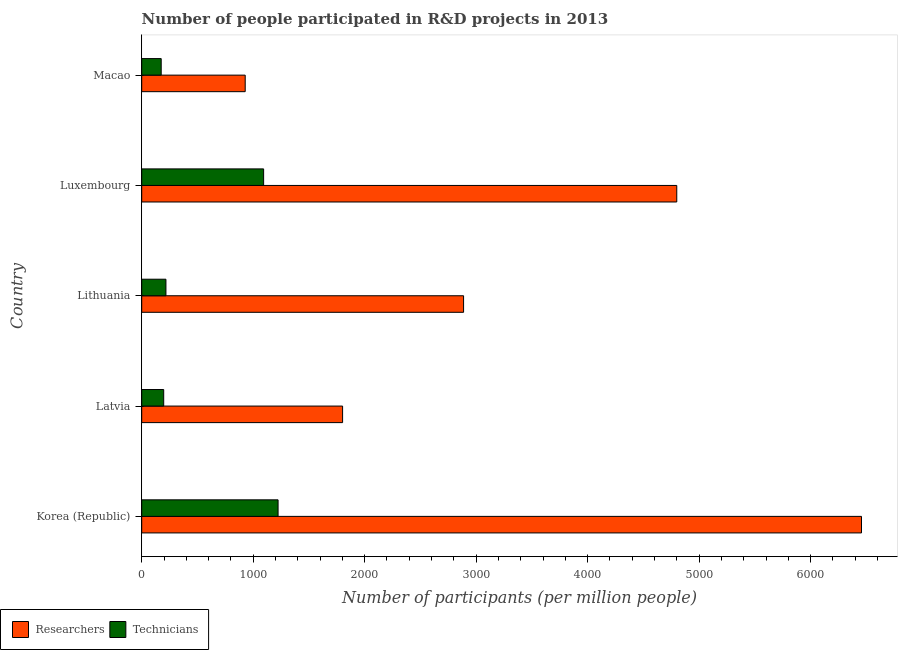How many groups of bars are there?
Your answer should be compact. 5. Are the number of bars on each tick of the Y-axis equal?
Your answer should be very brief. Yes. How many bars are there on the 3rd tick from the top?
Ensure brevity in your answer.  2. What is the label of the 4th group of bars from the top?
Offer a terse response. Latvia. In how many cases, is the number of bars for a given country not equal to the number of legend labels?
Give a very brief answer. 0. What is the number of researchers in Korea (Republic)?
Give a very brief answer. 6456.63. Across all countries, what is the maximum number of researchers?
Make the answer very short. 6456.63. Across all countries, what is the minimum number of technicians?
Provide a short and direct response. 174.68. In which country was the number of researchers minimum?
Keep it short and to the point. Macao. What is the total number of researchers in the graph?
Provide a short and direct response. 1.69e+04. What is the difference between the number of researchers in Korea (Republic) and that in Macao?
Offer a very short reply. 5528.37. What is the difference between the number of researchers in Luxembourg and the number of technicians in Macao?
Provide a short and direct response. 4624.86. What is the average number of researchers per country?
Give a very brief answer. 3374.68. What is the difference between the number of technicians and number of researchers in Luxembourg?
Your response must be concise. -3706.07. In how many countries, is the number of researchers greater than 800 ?
Provide a succinct answer. 5. What is the ratio of the number of technicians in Lithuania to that in Luxembourg?
Provide a short and direct response. 0.2. Is the difference between the number of researchers in Korea (Republic) and Luxembourg greater than the difference between the number of technicians in Korea (Republic) and Luxembourg?
Ensure brevity in your answer.  Yes. What is the difference between the highest and the second highest number of technicians?
Your response must be concise. 129.68. What is the difference between the highest and the lowest number of technicians?
Provide a short and direct response. 1048.47. In how many countries, is the number of technicians greater than the average number of technicians taken over all countries?
Give a very brief answer. 2. Is the sum of the number of technicians in Korea (Republic) and Luxembourg greater than the maximum number of researchers across all countries?
Provide a short and direct response. No. What does the 2nd bar from the top in Luxembourg represents?
Ensure brevity in your answer.  Researchers. What does the 1st bar from the bottom in Lithuania represents?
Give a very brief answer. Researchers. How many bars are there?
Keep it short and to the point. 10. Does the graph contain any zero values?
Your response must be concise. No. Does the graph contain grids?
Keep it short and to the point. No. Where does the legend appear in the graph?
Your response must be concise. Bottom left. What is the title of the graph?
Offer a terse response. Number of people participated in R&D projects in 2013. What is the label or title of the X-axis?
Offer a very short reply. Number of participants (per million people). What is the label or title of the Y-axis?
Offer a very short reply. Country. What is the Number of participants (per million people) in Researchers in Korea (Republic)?
Offer a terse response. 6456.63. What is the Number of participants (per million people) in Technicians in Korea (Republic)?
Your answer should be compact. 1223.15. What is the Number of participants (per million people) of Researchers in Latvia?
Your answer should be compact. 1801.82. What is the Number of participants (per million people) in Technicians in Latvia?
Give a very brief answer. 197.2. What is the Number of participants (per million people) of Researchers in Lithuania?
Your answer should be compact. 2887.16. What is the Number of participants (per million people) of Technicians in Lithuania?
Provide a succinct answer. 217.23. What is the Number of participants (per million people) of Researchers in Luxembourg?
Your answer should be very brief. 4799.54. What is the Number of participants (per million people) in Technicians in Luxembourg?
Keep it short and to the point. 1093.47. What is the Number of participants (per million people) in Researchers in Macao?
Offer a very short reply. 928.25. What is the Number of participants (per million people) in Technicians in Macao?
Make the answer very short. 174.68. Across all countries, what is the maximum Number of participants (per million people) of Researchers?
Make the answer very short. 6456.63. Across all countries, what is the maximum Number of participants (per million people) in Technicians?
Give a very brief answer. 1223.15. Across all countries, what is the minimum Number of participants (per million people) in Researchers?
Ensure brevity in your answer.  928.25. Across all countries, what is the minimum Number of participants (per million people) in Technicians?
Your answer should be compact. 174.68. What is the total Number of participants (per million people) of Researchers in the graph?
Offer a terse response. 1.69e+04. What is the total Number of participants (per million people) in Technicians in the graph?
Ensure brevity in your answer.  2905.73. What is the difference between the Number of participants (per million people) in Researchers in Korea (Republic) and that in Latvia?
Make the answer very short. 4654.81. What is the difference between the Number of participants (per million people) in Technicians in Korea (Republic) and that in Latvia?
Offer a terse response. 1025.95. What is the difference between the Number of participants (per million people) in Researchers in Korea (Republic) and that in Lithuania?
Your answer should be very brief. 3569.46. What is the difference between the Number of participants (per million people) in Technicians in Korea (Republic) and that in Lithuania?
Your answer should be compact. 1005.92. What is the difference between the Number of participants (per million people) in Researchers in Korea (Republic) and that in Luxembourg?
Make the answer very short. 1657.08. What is the difference between the Number of participants (per million people) of Technicians in Korea (Republic) and that in Luxembourg?
Your answer should be compact. 129.68. What is the difference between the Number of participants (per million people) of Researchers in Korea (Republic) and that in Macao?
Provide a short and direct response. 5528.37. What is the difference between the Number of participants (per million people) of Technicians in Korea (Republic) and that in Macao?
Offer a terse response. 1048.47. What is the difference between the Number of participants (per million people) of Researchers in Latvia and that in Lithuania?
Give a very brief answer. -1085.34. What is the difference between the Number of participants (per million people) in Technicians in Latvia and that in Lithuania?
Your answer should be very brief. -20.04. What is the difference between the Number of participants (per million people) of Researchers in Latvia and that in Luxembourg?
Offer a very short reply. -2997.73. What is the difference between the Number of participants (per million people) of Technicians in Latvia and that in Luxembourg?
Offer a terse response. -896.27. What is the difference between the Number of participants (per million people) of Researchers in Latvia and that in Macao?
Your answer should be very brief. 873.56. What is the difference between the Number of participants (per million people) in Technicians in Latvia and that in Macao?
Ensure brevity in your answer.  22.52. What is the difference between the Number of participants (per million people) in Researchers in Lithuania and that in Luxembourg?
Provide a succinct answer. -1912.38. What is the difference between the Number of participants (per million people) of Technicians in Lithuania and that in Luxembourg?
Provide a succinct answer. -876.24. What is the difference between the Number of participants (per million people) in Researchers in Lithuania and that in Macao?
Ensure brevity in your answer.  1958.91. What is the difference between the Number of participants (per million people) of Technicians in Lithuania and that in Macao?
Your answer should be very brief. 42.55. What is the difference between the Number of participants (per million people) in Researchers in Luxembourg and that in Macao?
Your answer should be compact. 3871.29. What is the difference between the Number of participants (per million people) of Technicians in Luxembourg and that in Macao?
Your answer should be compact. 918.79. What is the difference between the Number of participants (per million people) in Researchers in Korea (Republic) and the Number of participants (per million people) in Technicians in Latvia?
Your answer should be very brief. 6259.43. What is the difference between the Number of participants (per million people) in Researchers in Korea (Republic) and the Number of participants (per million people) in Technicians in Lithuania?
Make the answer very short. 6239.39. What is the difference between the Number of participants (per million people) of Researchers in Korea (Republic) and the Number of participants (per million people) of Technicians in Luxembourg?
Ensure brevity in your answer.  5363.16. What is the difference between the Number of participants (per million people) of Researchers in Korea (Republic) and the Number of participants (per million people) of Technicians in Macao?
Give a very brief answer. 6281.94. What is the difference between the Number of participants (per million people) in Researchers in Latvia and the Number of participants (per million people) in Technicians in Lithuania?
Offer a very short reply. 1584.58. What is the difference between the Number of participants (per million people) in Researchers in Latvia and the Number of participants (per million people) in Technicians in Luxembourg?
Provide a short and direct response. 708.35. What is the difference between the Number of participants (per million people) in Researchers in Latvia and the Number of participants (per million people) in Technicians in Macao?
Your answer should be very brief. 1627.14. What is the difference between the Number of participants (per million people) in Researchers in Lithuania and the Number of participants (per million people) in Technicians in Luxembourg?
Your response must be concise. 1793.69. What is the difference between the Number of participants (per million people) in Researchers in Lithuania and the Number of participants (per million people) in Technicians in Macao?
Ensure brevity in your answer.  2712.48. What is the difference between the Number of participants (per million people) in Researchers in Luxembourg and the Number of participants (per million people) in Technicians in Macao?
Provide a short and direct response. 4624.86. What is the average Number of participants (per million people) of Researchers per country?
Give a very brief answer. 3374.68. What is the average Number of participants (per million people) of Technicians per country?
Offer a very short reply. 581.15. What is the difference between the Number of participants (per million people) in Researchers and Number of participants (per million people) in Technicians in Korea (Republic)?
Provide a succinct answer. 5233.47. What is the difference between the Number of participants (per million people) in Researchers and Number of participants (per million people) in Technicians in Latvia?
Make the answer very short. 1604.62. What is the difference between the Number of participants (per million people) in Researchers and Number of participants (per million people) in Technicians in Lithuania?
Your answer should be very brief. 2669.93. What is the difference between the Number of participants (per million people) of Researchers and Number of participants (per million people) of Technicians in Luxembourg?
Provide a succinct answer. 3706.07. What is the difference between the Number of participants (per million people) in Researchers and Number of participants (per million people) in Technicians in Macao?
Offer a terse response. 753.57. What is the ratio of the Number of participants (per million people) of Researchers in Korea (Republic) to that in Latvia?
Provide a short and direct response. 3.58. What is the ratio of the Number of participants (per million people) of Technicians in Korea (Republic) to that in Latvia?
Make the answer very short. 6.2. What is the ratio of the Number of participants (per million people) in Researchers in Korea (Republic) to that in Lithuania?
Give a very brief answer. 2.24. What is the ratio of the Number of participants (per million people) of Technicians in Korea (Republic) to that in Lithuania?
Make the answer very short. 5.63. What is the ratio of the Number of participants (per million people) in Researchers in Korea (Republic) to that in Luxembourg?
Your response must be concise. 1.35. What is the ratio of the Number of participants (per million people) in Technicians in Korea (Republic) to that in Luxembourg?
Provide a succinct answer. 1.12. What is the ratio of the Number of participants (per million people) in Researchers in Korea (Republic) to that in Macao?
Your response must be concise. 6.96. What is the ratio of the Number of participants (per million people) in Technicians in Korea (Republic) to that in Macao?
Your answer should be compact. 7. What is the ratio of the Number of participants (per million people) of Researchers in Latvia to that in Lithuania?
Give a very brief answer. 0.62. What is the ratio of the Number of participants (per million people) of Technicians in Latvia to that in Lithuania?
Give a very brief answer. 0.91. What is the ratio of the Number of participants (per million people) in Researchers in Latvia to that in Luxembourg?
Keep it short and to the point. 0.38. What is the ratio of the Number of participants (per million people) in Technicians in Latvia to that in Luxembourg?
Provide a short and direct response. 0.18. What is the ratio of the Number of participants (per million people) in Researchers in Latvia to that in Macao?
Offer a very short reply. 1.94. What is the ratio of the Number of participants (per million people) of Technicians in Latvia to that in Macao?
Offer a very short reply. 1.13. What is the ratio of the Number of participants (per million people) of Researchers in Lithuania to that in Luxembourg?
Offer a very short reply. 0.6. What is the ratio of the Number of participants (per million people) in Technicians in Lithuania to that in Luxembourg?
Your answer should be compact. 0.2. What is the ratio of the Number of participants (per million people) of Researchers in Lithuania to that in Macao?
Make the answer very short. 3.11. What is the ratio of the Number of participants (per million people) in Technicians in Lithuania to that in Macao?
Your answer should be very brief. 1.24. What is the ratio of the Number of participants (per million people) in Researchers in Luxembourg to that in Macao?
Ensure brevity in your answer.  5.17. What is the ratio of the Number of participants (per million people) in Technicians in Luxembourg to that in Macao?
Provide a succinct answer. 6.26. What is the difference between the highest and the second highest Number of participants (per million people) of Researchers?
Provide a short and direct response. 1657.08. What is the difference between the highest and the second highest Number of participants (per million people) of Technicians?
Provide a succinct answer. 129.68. What is the difference between the highest and the lowest Number of participants (per million people) of Researchers?
Your answer should be very brief. 5528.37. What is the difference between the highest and the lowest Number of participants (per million people) of Technicians?
Provide a short and direct response. 1048.47. 